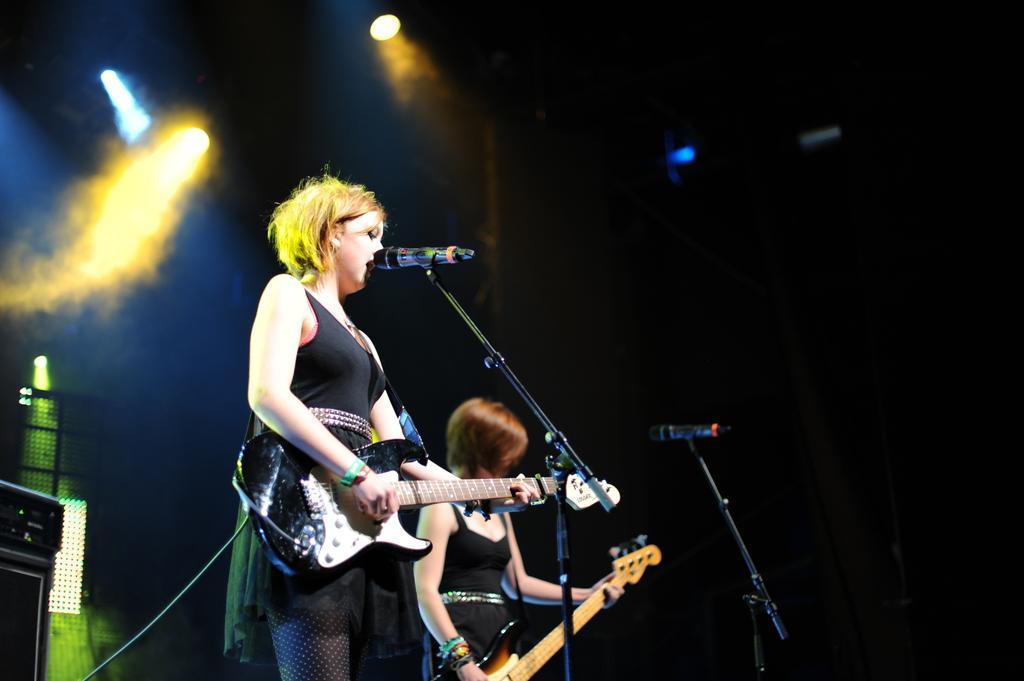Please provide a concise description of this image. There is a women in the foreground of the image who is playing guitar and singing a song by using a mike. And there is a another woman at the background,who is holding guitar. And i can see two mics with their mic stands. And it seems like a stage show where they are performing. And at the background I can see a speaker,and these are the kind of flood lights which are used to highlight the show. These women are wearing black dress and playing guitar. 